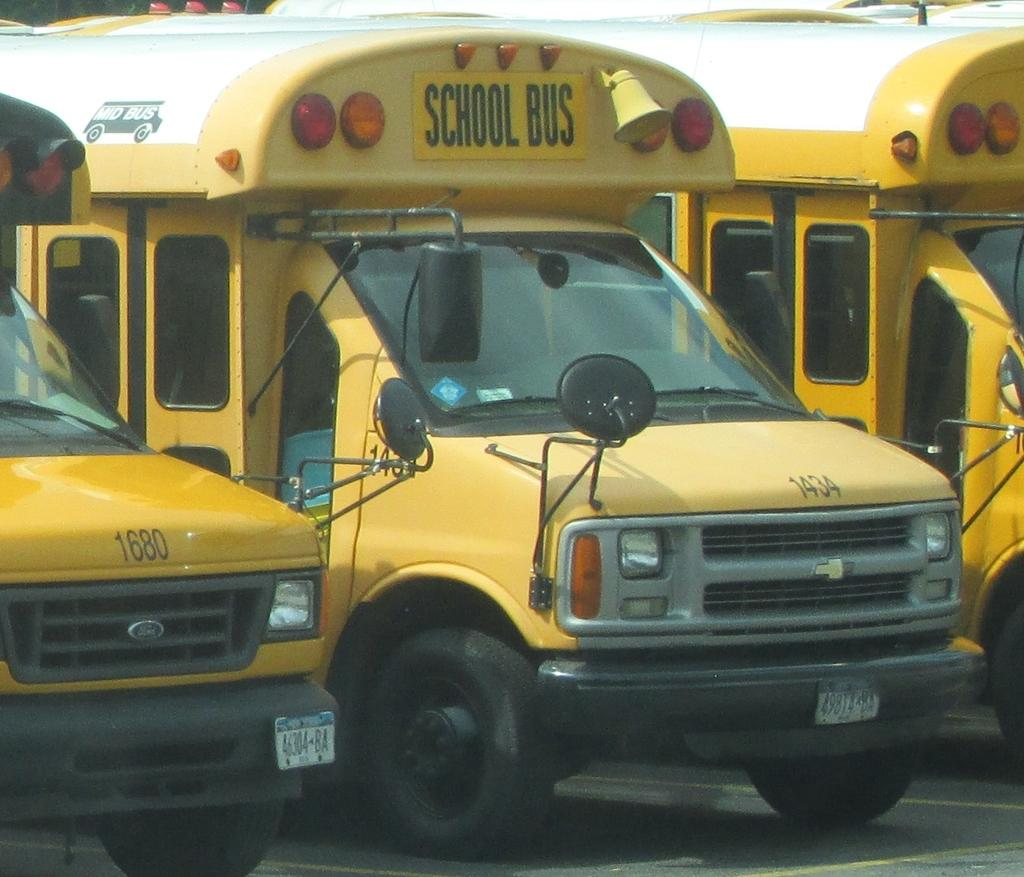<image>
Present a compact description of the photo's key features. A yellow bus with the words School Bus written on it. 